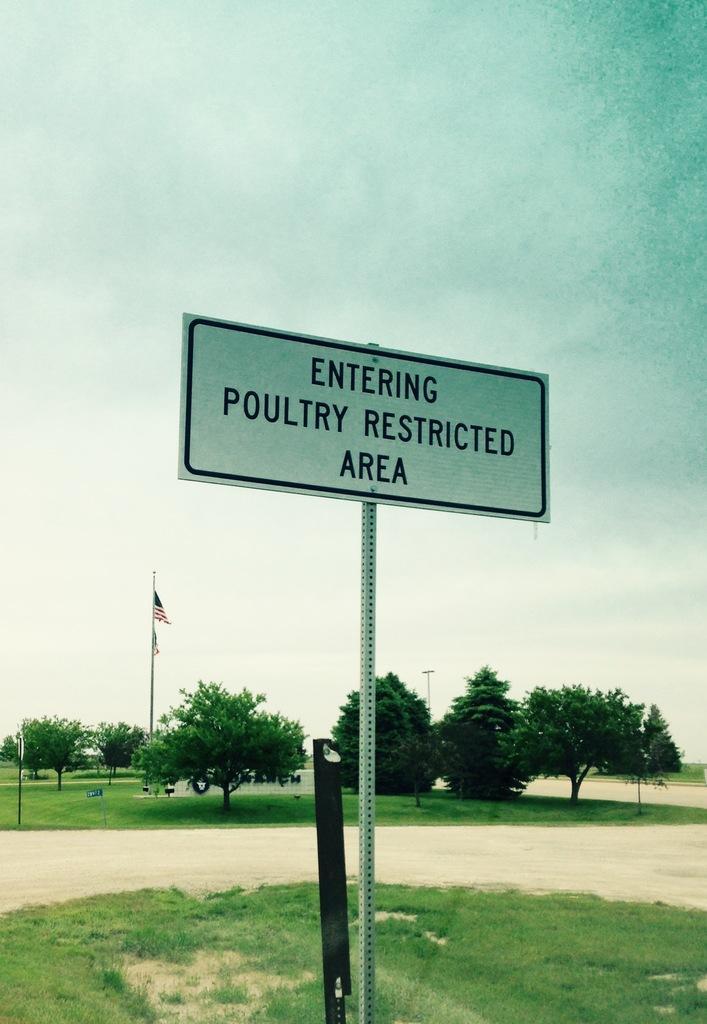Can you describe this image briefly? In this picture there are trees and there is a flag. In the foreground there is a board on the pole and there is text on the board. At the top there is sky. At the bottom there is grass and there is ground. 